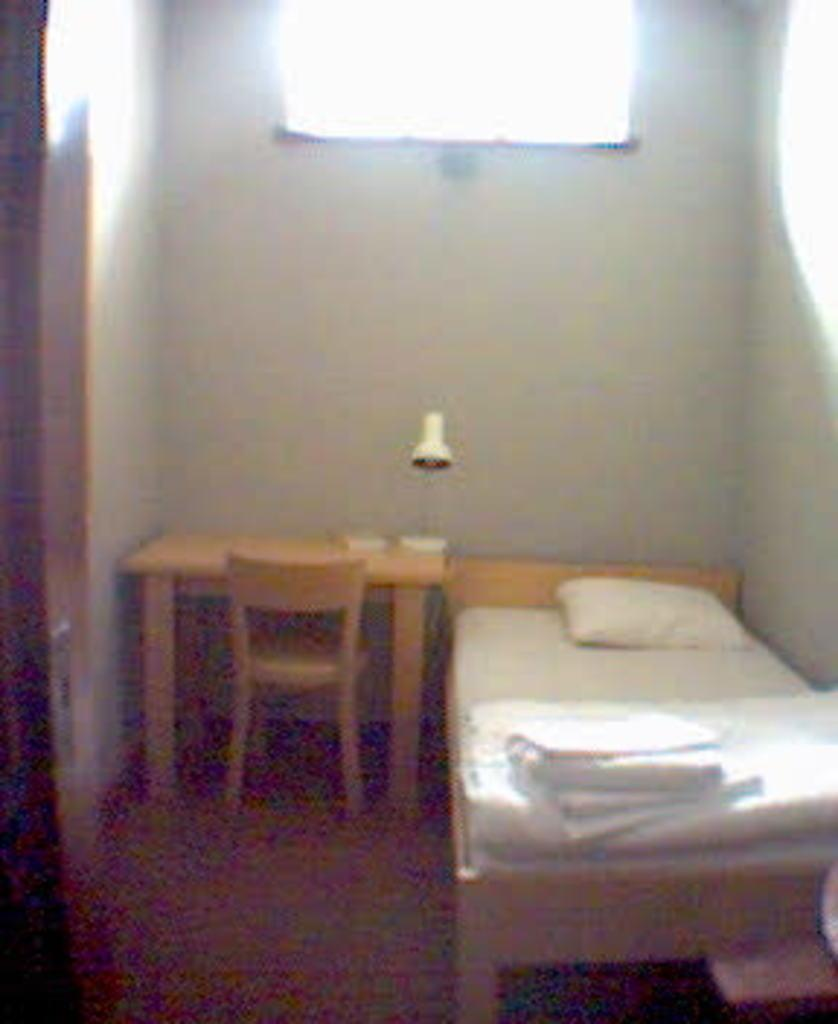What type of furniture is present in the image? There is a bed, a chair, and a table in the image. What is on the bed in the image? The bed has blankets and a pillow. What is the purpose of the table lamp in the image? The table lamp is likely used for providing light in the room. What can be seen through the window in the image? The specific view through the window is not mentioned, but it is clear that there is a window present. What is visible in the background of the image? There is a wall visible in the background of the image. How many cubs are playing on the bed in the image? There are no cubs present in the image; it features a bed with blankets and a pillow. Can you describe the person sitting in the chair in the image? There is no person sitting in the chair in the image; only the chair itself is visible. 